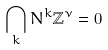Convert formula to latex. <formula><loc_0><loc_0><loc_500><loc_500>\bigcap _ { k } N ^ { k } \mathbb { Z } ^ { \nu } = 0</formula> 